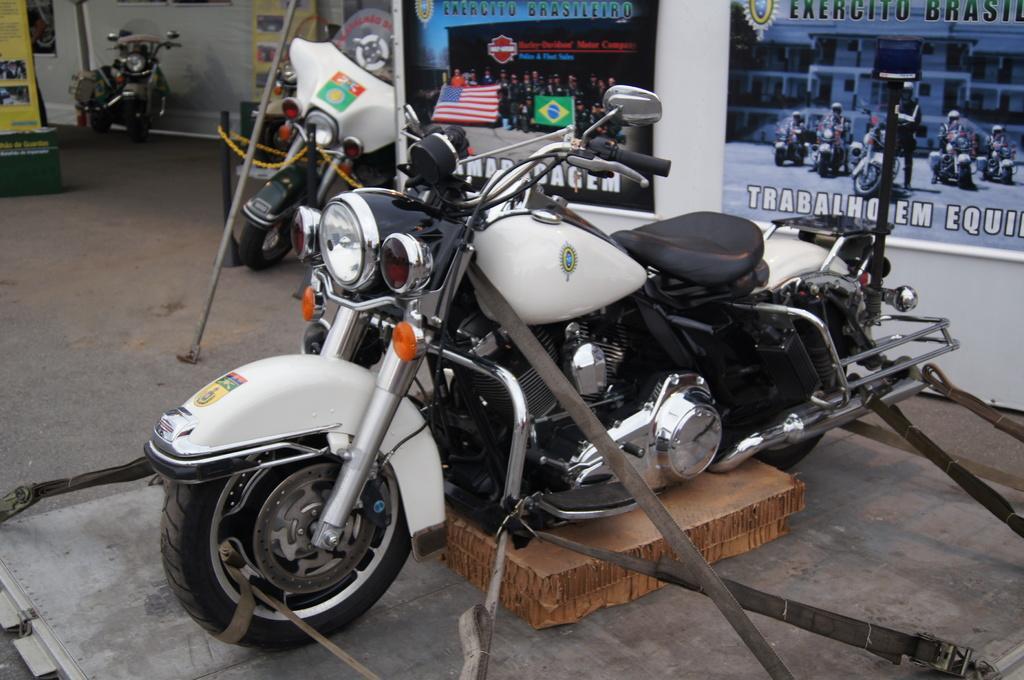Describe this image in one or two sentences. In this image I can see a motor bike which is white and black in color is tied with belts to the surface. In the background I can see few other motor bikes, few yellow colored banners and few blue and black colored banners attached to the white colored wall. 